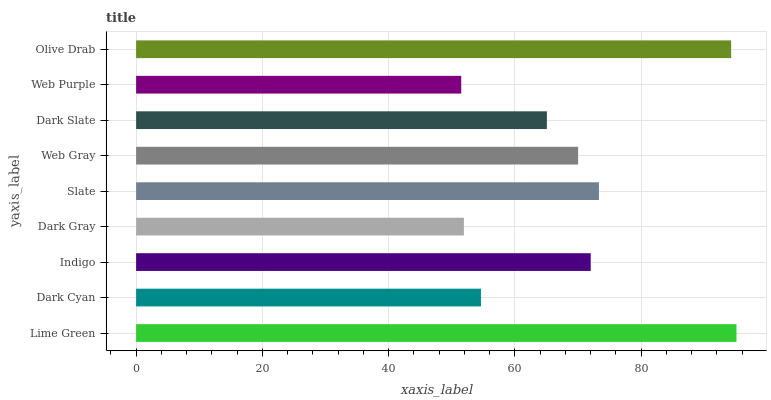Is Web Purple the minimum?
Answer yes or no. Yes. Is Lime Green the maximum?
Answer yes or no. Yes. Is Dark Cyan the minimum?
Answer yes or no. No. Is Dark Cyan the maximum?
Answer yes or no. No. Is Lime Green greater than Dark Cyan?
Answer yes or no. Yes. Is Dark Cyan less than Lime Green?
Answer yes or no. Yes. Is Dark Cyan greater than Lime Green?
Answer yes or no. No. Is Lime Green less than Dark Cyan?
Answer yes or no. No. Is Web Gray the high median?
Answer yes or no. Yes. Is Web Gray the low median?
Answer yes or no. Yes. Is Indigo the high median?
Answer yes or no. No. Is Slate the low median?
Answer yes or no. No. 